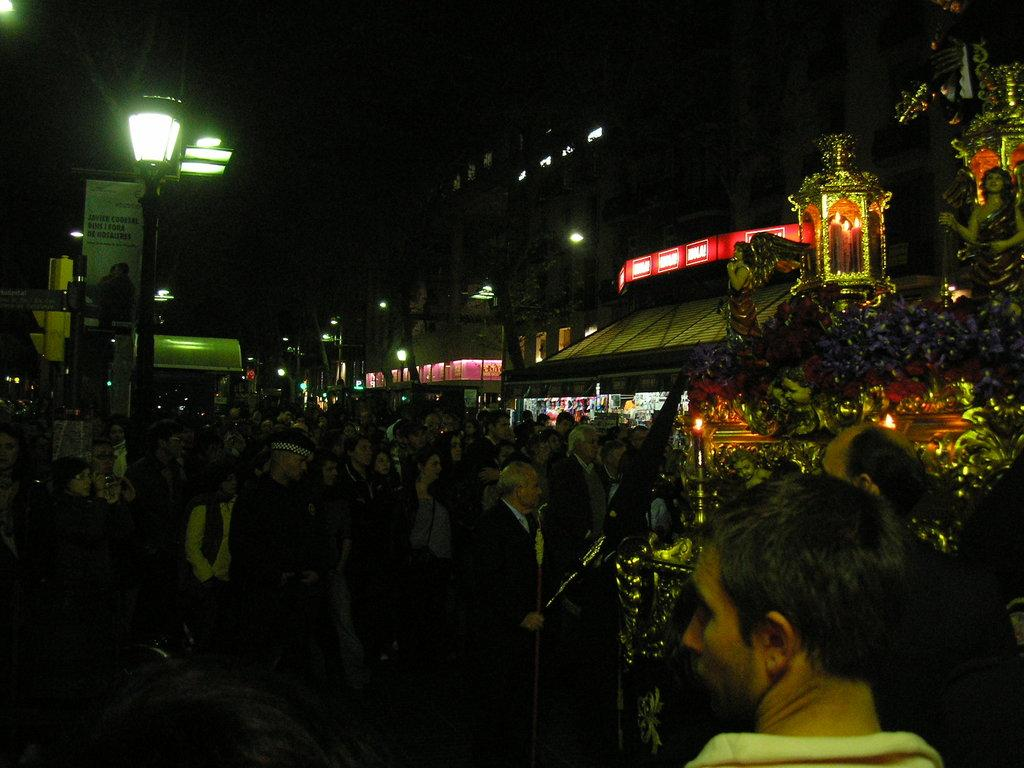What is happening in the image? There are people standing in the image. What can be seen in the background of the image? There are multiple buildings in the image. What type of marble is being used to build the animal in the image? There is no marble or animal present in the image; it features people standing and multiple buildings. 